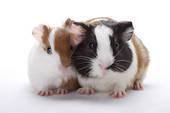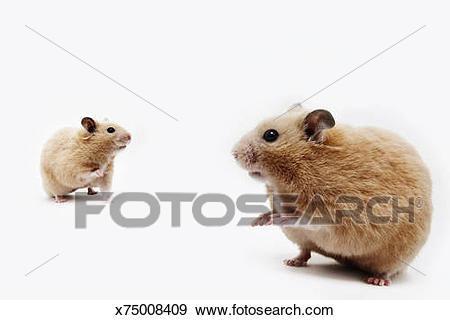The first image is the image on the left, the second image is the image on the right. Assess this claim about the two images: "One rodent sits alone in the image on the right.". Correct or not? Answer yes or no. No. The first image is the image on the left, the second image is the image on the right. Assess this claim about the two images: "Each image contains multiple pet rodents, and at least one image shows two rodents posed so one has its head directly above the other.". Correct or not? Answer yes or no. No. 